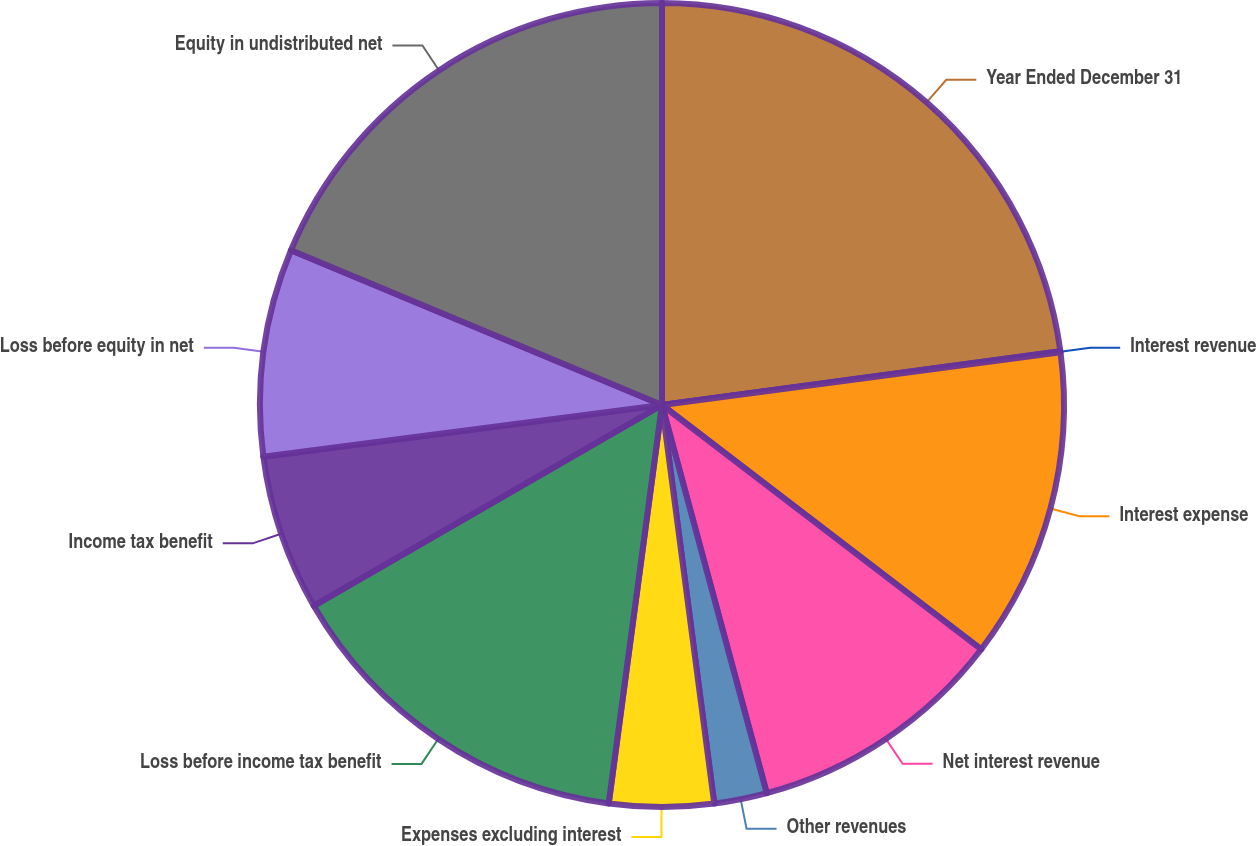Convert chart. <chart><loc_0><loc_0><loc_500><loc_500><pie_chart><fcel>Year Ended December 31<fcel>Interest revenue<fcel>Interest expense<fcel>Net interest revenue<fcel>Other revenues<fcel>Expenses excluding interest<fcel>Loss before income tax benefit<fcel>Income tax benefit<fcel>Loss before equity in net<fcel>Equity in undistributed net<nl><fcel>22.86%<fcel>0.04%<fcel>12.49%<fcel>10.41%<fcel>2.12%<fcel>4.19%<fcel>14.56%<fcel>6.27%<fcel>8.34%<fcel>18.71%<nl></chart> 